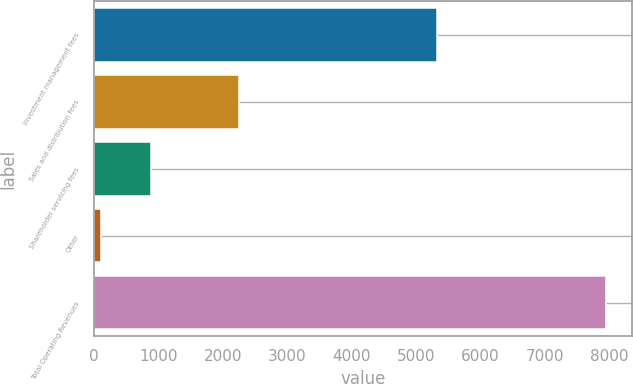Convert chart to OTSL. <chart><loc_0><loc_0><loc_500><loc_500><bar_chart><fcel>Investment management fees<fcel>Sales and distribution fees<fcel>Shareholder servicing fees<fcel>Other<fcel>Total Operating Revenues<nl><fcel>5327.8<fcel>2252.4<fcel>890<fcel>105.7<fcel>7948.7<nl></chart> 